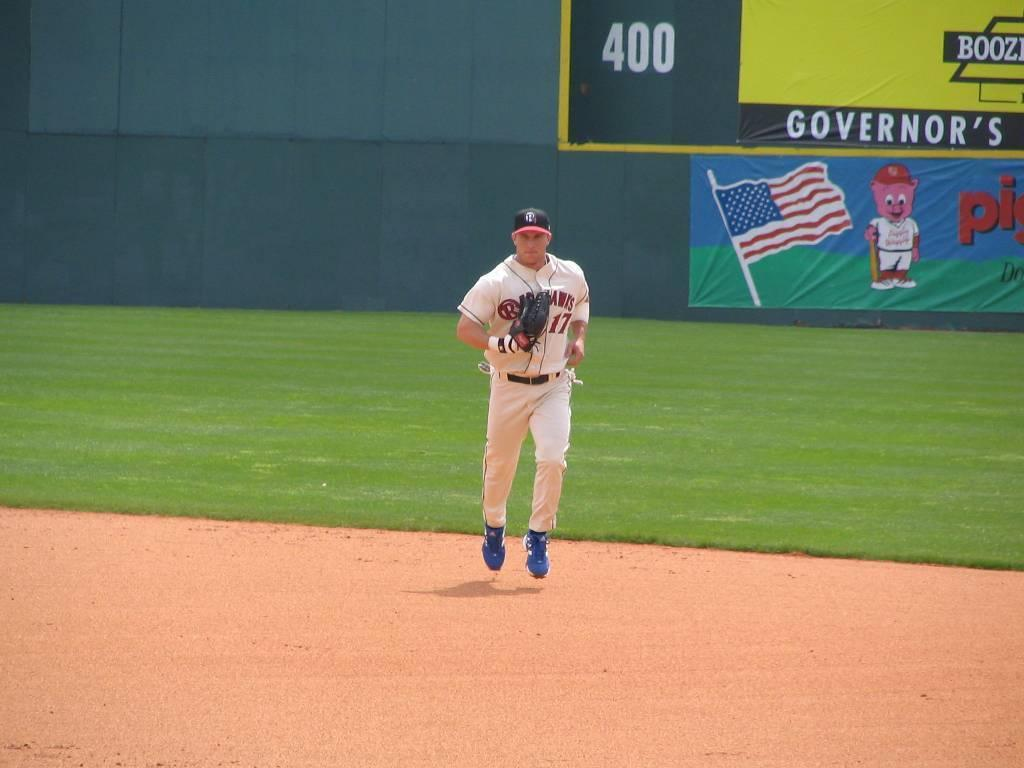<image>
Write a terse but informative summary of the picture. an outfielder runs towards the center of the field while there are 400 points on the score board. 